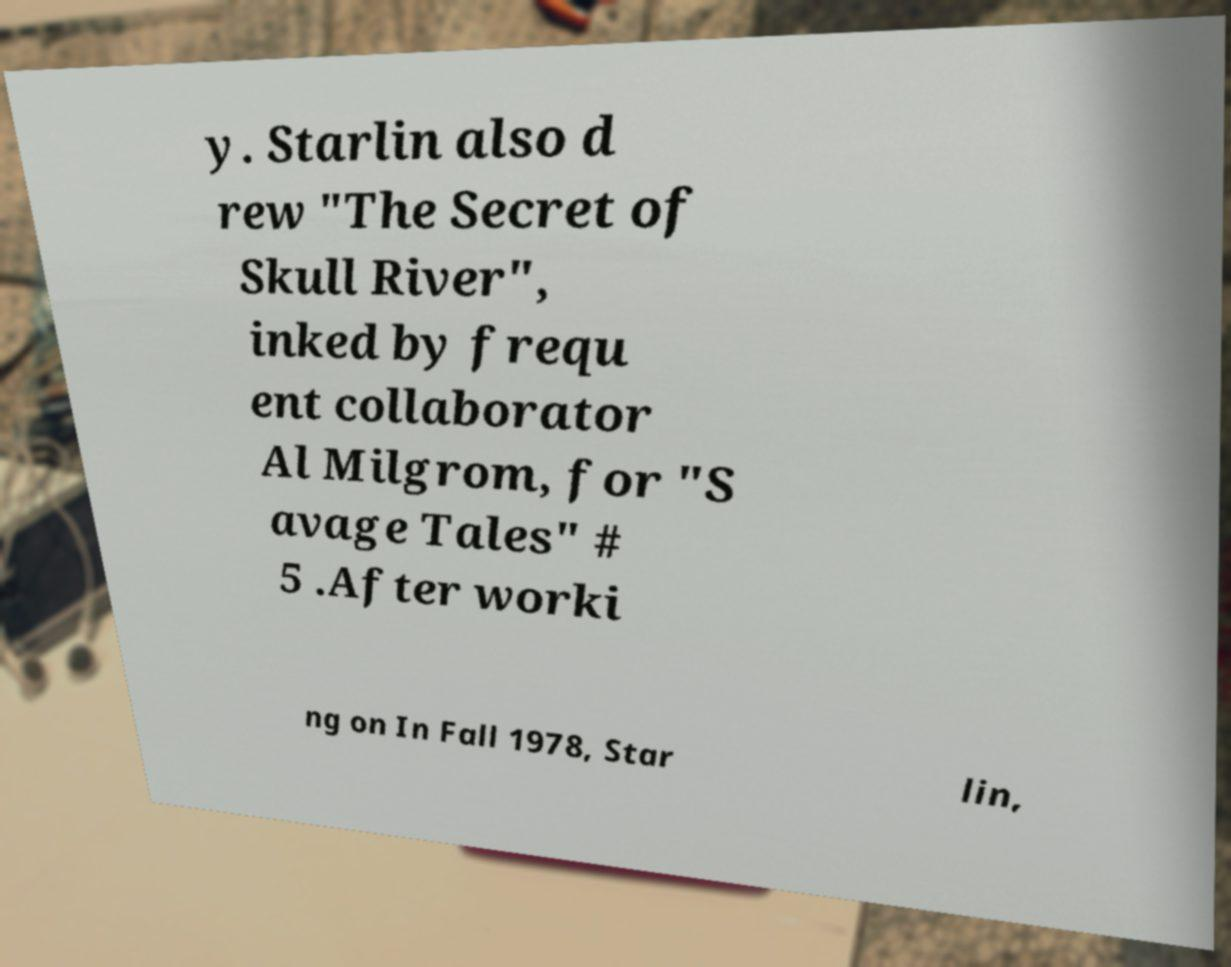Please identify and transcribe the text found in this image. y. Starlin also d rew "The Secret of Skull River", inked by frequ ent collaborator Al Milgrom, for "S avage Tales" # 5 .After worki ng on In Fall 1978, Star lin, 